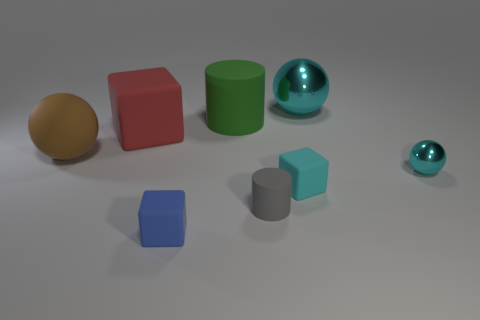Subtract all brown blocks. Subtract all purple spheres. How many blocks are left? 3 Add 1 gray cylinders. How many objects exist? 9 Subtract all spheres. How many objects are left? 5 Add 3 small blue cylinders. How many small blue cylinders exist? 3 Subtract 1 gray cylinders. How many objects are left? 7 Subtract all cyan metallic blocks. Subtract all big cyan balls. How many objects are left? 7 Add 3 cyan metal objects. How many cyan metal objects are left? 5 